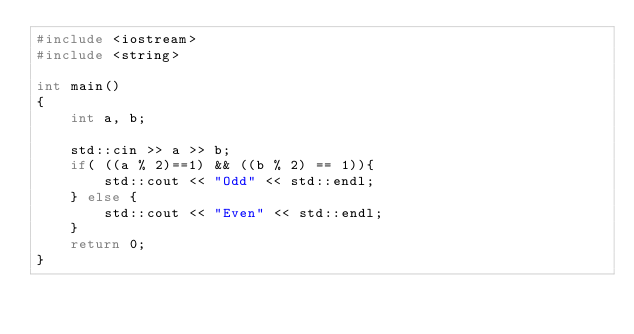Convert code to text. <code><loc_0><loc_0><loc_500><loc_500><_C++_>#include <iostream>
#include <string>

int main()
{
    int a, b;

    std::cin >> a >> b;
    if( ((a % 2)==1) && ((b % 2) == 1)){
        std::cout << "Odd" << std::endl;
    } else {
        std::cout << "Even" << std::endl;
    }
    return 0;
}</code> 